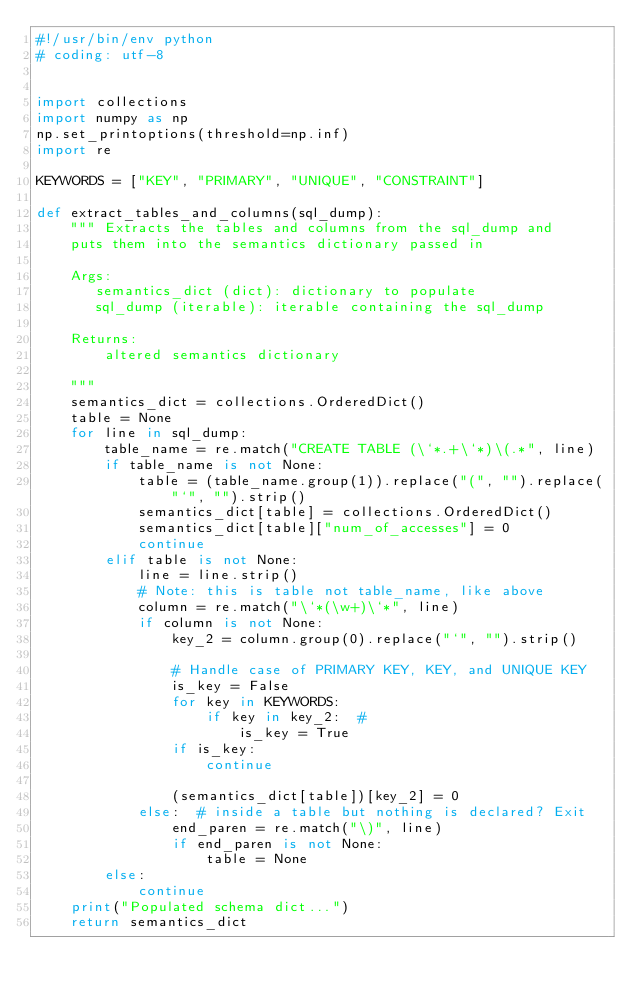<code> <loc_0><loc_0><loc_500><loc_500><_Python_>#!/usr/bin/env python
# coding: utf-8


import collections
import numpy as np
np.set_printoptions(threshold=np.inf)
import re

KEYWORDS = ["KEY", "PRIMARY", "UNIQUE", "CONSTRAINT"]

def extract_tables_and_columns(sql_dump):
    """ Extracts the tables and columns from the sql_dump and
    puts them into the semantics dictionary passed in

    Args:
       semantics_dict (dict): dictionary to populate
       sql_dump (iterable): iterable containing the sql_dump

    Returns:
        altered semantics dictionary

    """
    semantics_dict = collections.OrderedDict()
    table = None
    for line in sql_dump:
        table_name = re.match("CREATE TABLE (\`*.+\`*)\(.*", line)
        if table_name is not None:
            table = (table_name.group(1)).replace("(", "").replace("`", "").strip()
            semantics_dict[table] = collections.OrderedDict()
            semantics_dict[table]["num_of_accesses"] = 0
            continue
        elif table is not None:
            line = line.strip()
            # Note: this is table not table_name, like above
            column = re.match("\`*(\w+)\`*", line)
            if column is not None:
                key_2 = column.group(0).replace("`", "").strip()

                # Handle case of PRIMARY KEY, KEY, and UNIQUE KEY
                is_key = False
                for key in KEYWORDS:
                    if key in key_2:  #
                        is_key = True
                if is_key:
                    continue

                (semantics_dict[table])[key_2] = 0
            else:  # inside a table but nothing is declared? Exit
                end_paren = re.match("\)", line)
                if end_paren is not None:
                    table = None
        else:
            continue
    print("Populated schema dict...")
    return semantics_dict
</code> 